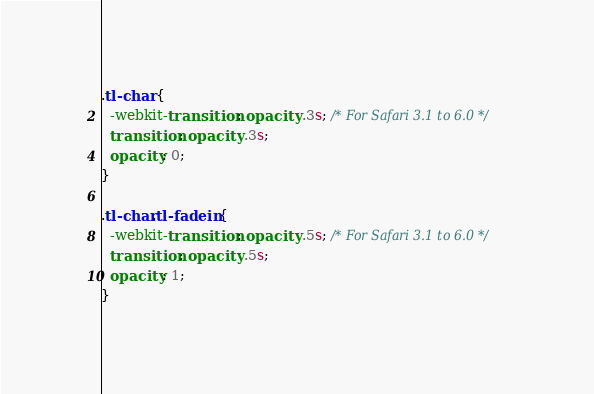<code> <loc_0><loc_0><loc_500><loc_500><_CSS_>.tl-char {
  -webkit-transition: opacity .3s; /* For Safari 3.1 to 6.0 */
  transition: opacity .3s;
  opacity: 0;
}

.tl-char.tl-fadein {
  -webkit-transition: opacity .5s; /* For Safari 3.1 to 6.0 */
  transition: opacity .5s;
  opacity: 1;
}

</code> 